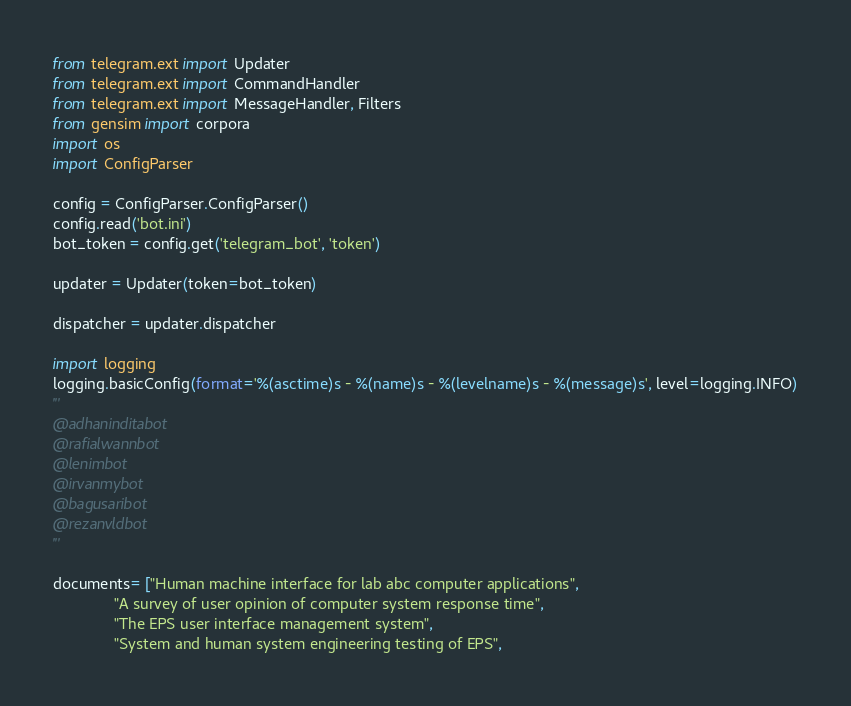Convert code to text. <code><loc_0><loc_0><loc_500><loc_500><_Python_>from telegram.ext import Updater
from telegram.ext import CommandHandler
from telegram.ext import MessageHandler, Filters
from gensim import corpora
import os
import ConfigParser

config = ConfigParser.ConfigParser()
config.read('bot.ini')
bot_token = config.get('telegram_bot', 'token')

updater = Updater(token=bot_token)

dispatcher = updater.dispatcher

import logging
logging.basicConfig(format='%(asctime)s - %(name)s - %(levelname)s - %(message)s', level=logging.INFO)
'''
@adhaninditabot
@rafialwannbot
@lenimbot
@irvanmybot
@bagusaribot
@rezanvldbot
'''

documents= ["Human machine interface for lab abc computer applications",
              "A survey of user opinion of computer system response time",
              "The EPS user interface management system",
              "System and human system engineering testing of EPS",</code> 